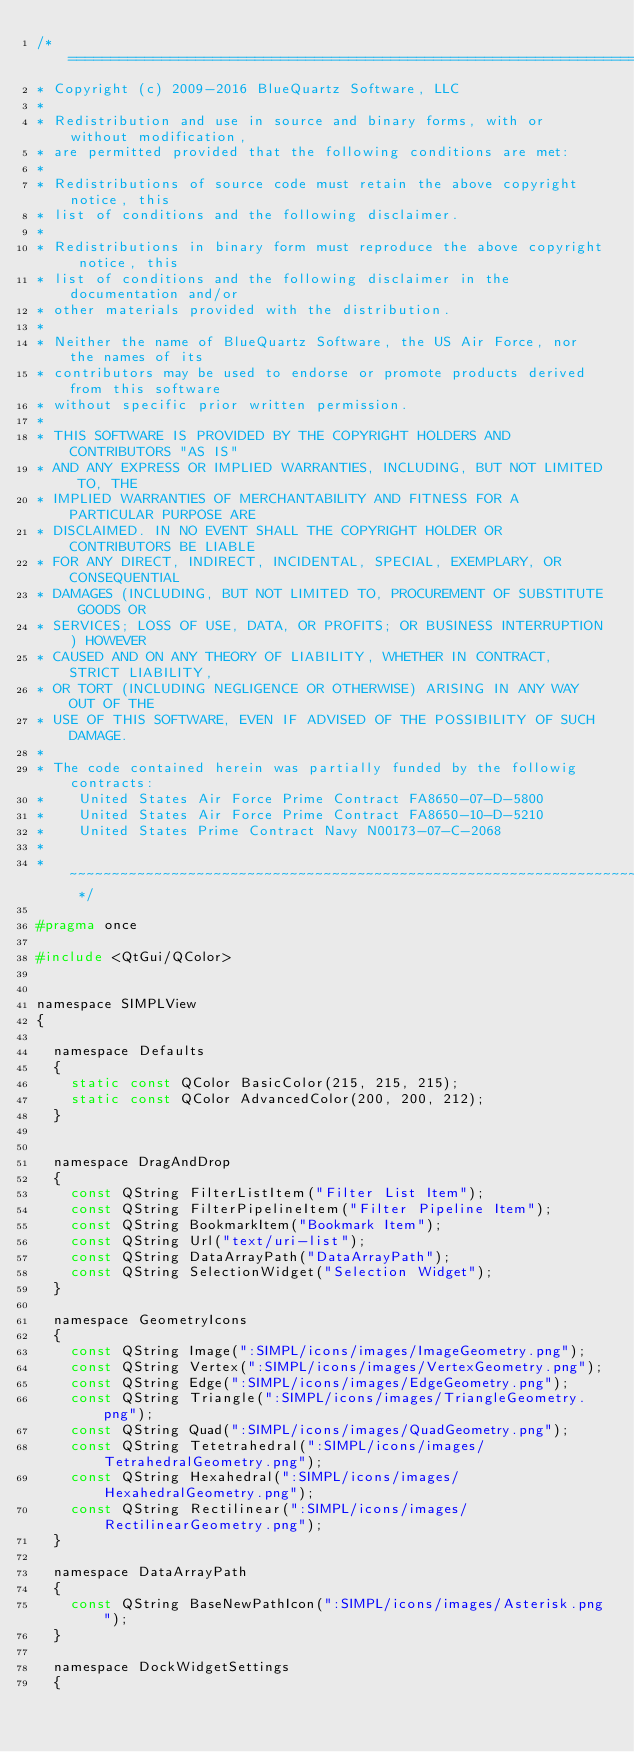Convert code to text. <code><loc_0><loc_0><loc_500><loc_500><_C_>/* ============================================================================
* Copyright (c) 2009-2016 BlueQuartz Software, LLC
*
* Redistribution and use in source and binary forms, with or without modification,
* are permitted provided that the following conditions are met:
*
* Redistributions of source code must retain the above copyright notice, this
* list of conditions and the following disclaimer.
*
* Redistributions in binary form must reproduce the above copyright notice, this
* list of conditions and the following disclaimer in the documentation and/or
* other materials provided with the distribution.
*
* Neither the name of BlueQuartz Software, the US Air Force, nor the names of its
* contributors may be used to endorse or promote products derived from this software
* without specific prior written permission.
*
* THIS SOFTWARE IS PROVIDED BY THE COPYRIGHT HOLDERS AND CONTRIBUTORS "AS IS"
* AND ANY EXPRESS OR IMPLIED WARRANTIES, INCLUDING, BUT NOT LIMITED TO, THE
* IMPLIED WARRANTIES OF MERCHANTABILITY AND FITNESS FOR A PARTICULAR PURPOSE ARE
* DISCLAIMED. IN NO EVENT SHALL THE COPYRIGHT HOLDER OR CONTRIBUTORS BE LIABLE
* FOR ANY DIRECT, INDIRECT, INCIDENTAL, SPECIAL, EXEMPLARY, OR CONSEQUENTIAL
* DAMAGES (INCLUDING, BUT NOT LIMITED TO, PROCUREMENT OF SUBSTITUTE GOODS OR
* SERVICES; LOSS OF USE, DATA, OR PROFITS; OR BUSINESS INTERRUPTION) HOWEVER
* CAUSED AND ON ANY THEORY OF LIABILITY, WHETHER IN CONTRACT, STRICT LIABILITY,
* OR TORT (INCLUDING NEGLIGENCE OR OTHERWISE) ARISING IN ANY WAY OUT OF THE
* USE OF THIS SOFTWARE, EVEN IF ADVISED OF THE POSSIBILITY OF SUCH DAMAGE.
*
* The code contained herein was partially funded by the followig contracts:
*    United States Air Force Prime Contract FA8650-07-D-5800
*    United States Air Force Prime Contract FA8650-10-D-5210
*    United States Prime Contract Navy N00173-07-C-2068
*
* ~~~~~~~~~~~~~~~~~~~~~~~~~~~~~~~~~~~~~~~~~~~~~~~~~~~~~~~~~~~~~~~~~~~~~~~~~~ */

#pragma once

#include <QtGui/QColor>


namespace SIMPLView
{

  namespace Defaults
  {
    static const QColor BasicColor(215, 215, 215);
    static const QColor AdvancedColor(200, 200, 212);
  }


  namespace DragAndDrop
  {
    const QString FilterListItem("Filter List Item");
    const QString FilterPipelineItem("Filter Pipeline Item");
    const QString BookmarkItem("Bookmark Item");
    const QString Url("text/uri-list");
    const QString DataArrayPath("DataArrayPath");
    const QString SelectionWidget("Selection Widget");
  }

  namespace GeometryIcons
  {
    const QString Image(":SIMPL/icons/images/ImageGeometry.png");
    const QString Vertex(":SIMPL/icons/images/VertexGeometry.png");
    const QString Edge(":SIMPL/icons/images/EdgeGeometry.png");
    const QString Triangle(":SIMPL/icons/images/TriangleGeometry.png");
    const QString Quad(":SIMPL/icons/images/QuadGeometry.png");
    const QString Tetetrahedral(":SIMPL/icons/images/TetrahedralGeometry.png");
    const QString Hexahedral(":SIMPL/icons/images/HexahedralGeometry.png");
    const QString Rectilinear(":SIMPL/icons/images/RectilinearGeometry.png");
  }

  namespace DataArrayPath
  {
    const QString BaseNewPathIcon(":SIMPL/icons/images/Asterisk.png");
  }

  namespace DockWidgetSettings
  {</code> 